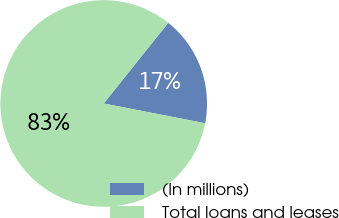<chart> <loc_0><loc_0><loc_500><loc_500><pie_chart><fcel>(In millions)<fcel>Total loans and leases<nl><fcel>17.33%<fcel>82.67%<nl></chart> 